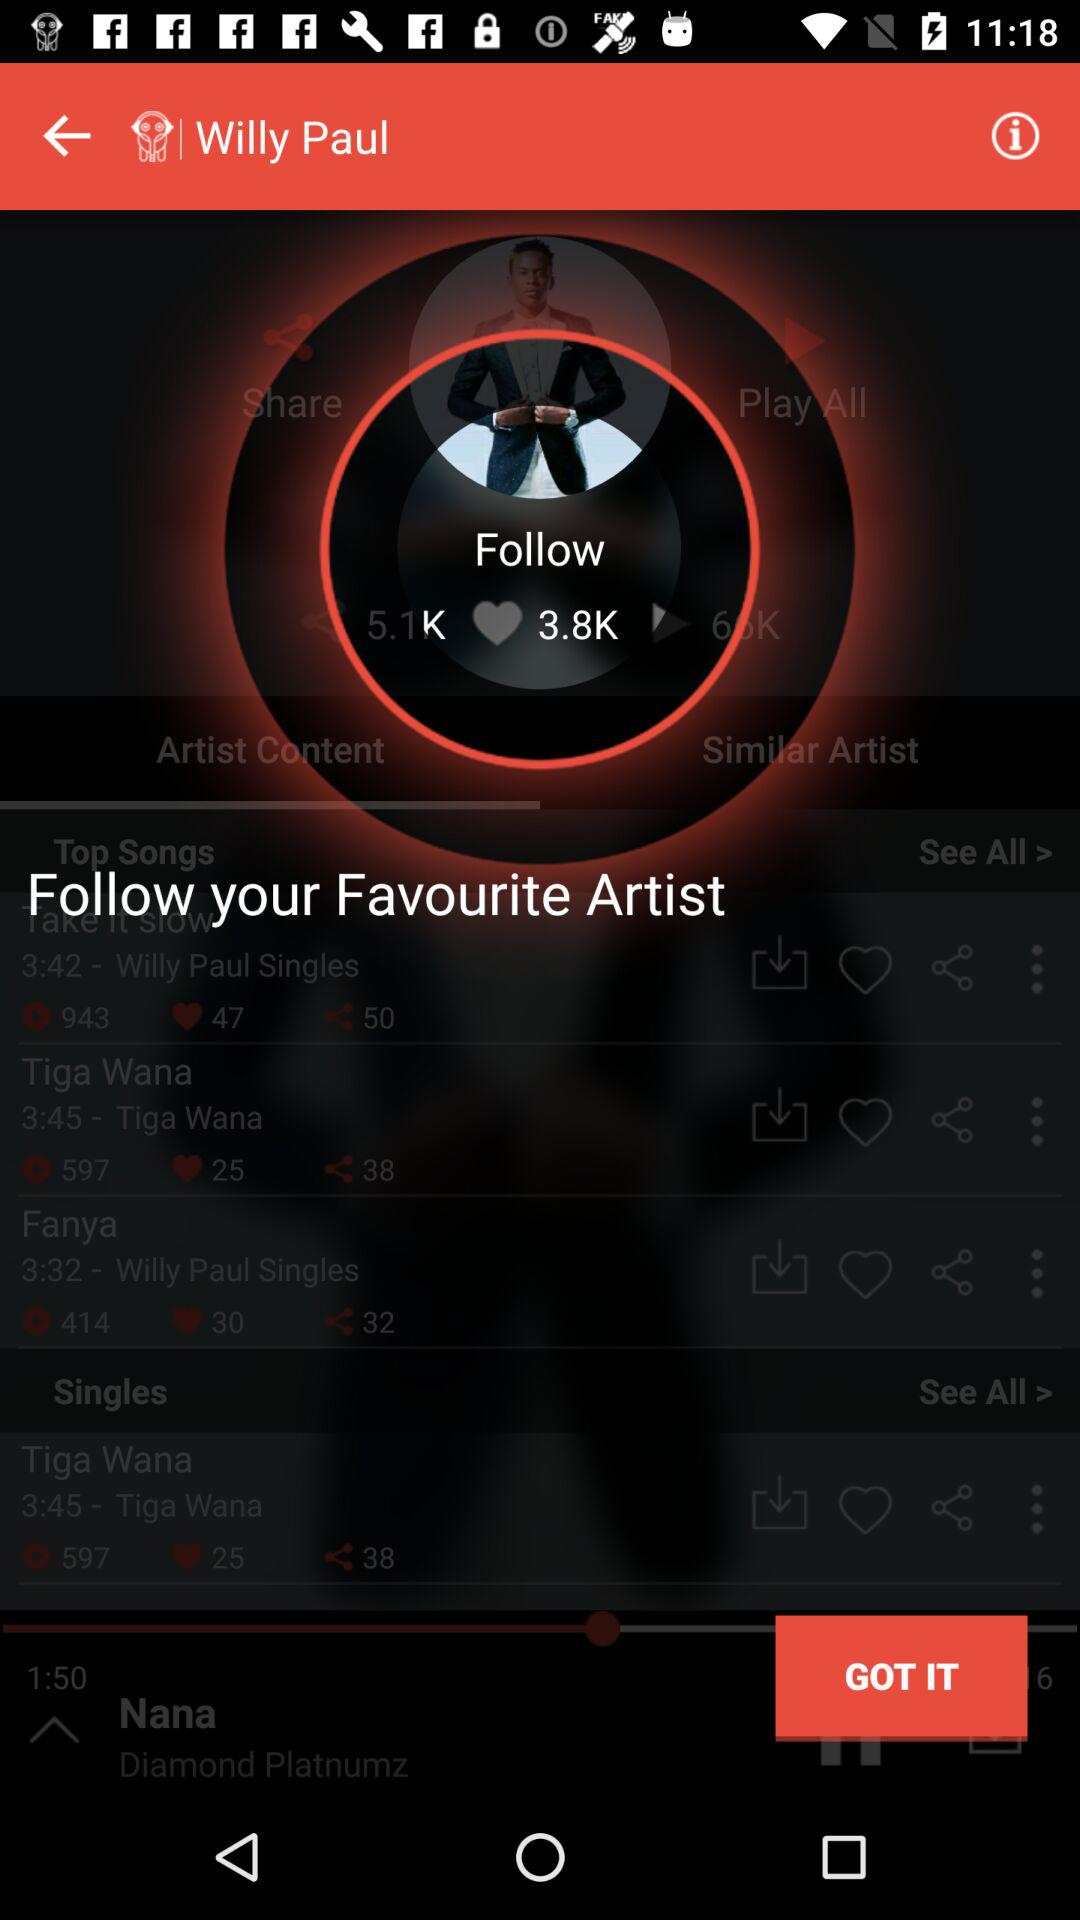How many likes are there for the song "Take it slow"? There are 47 likes. 